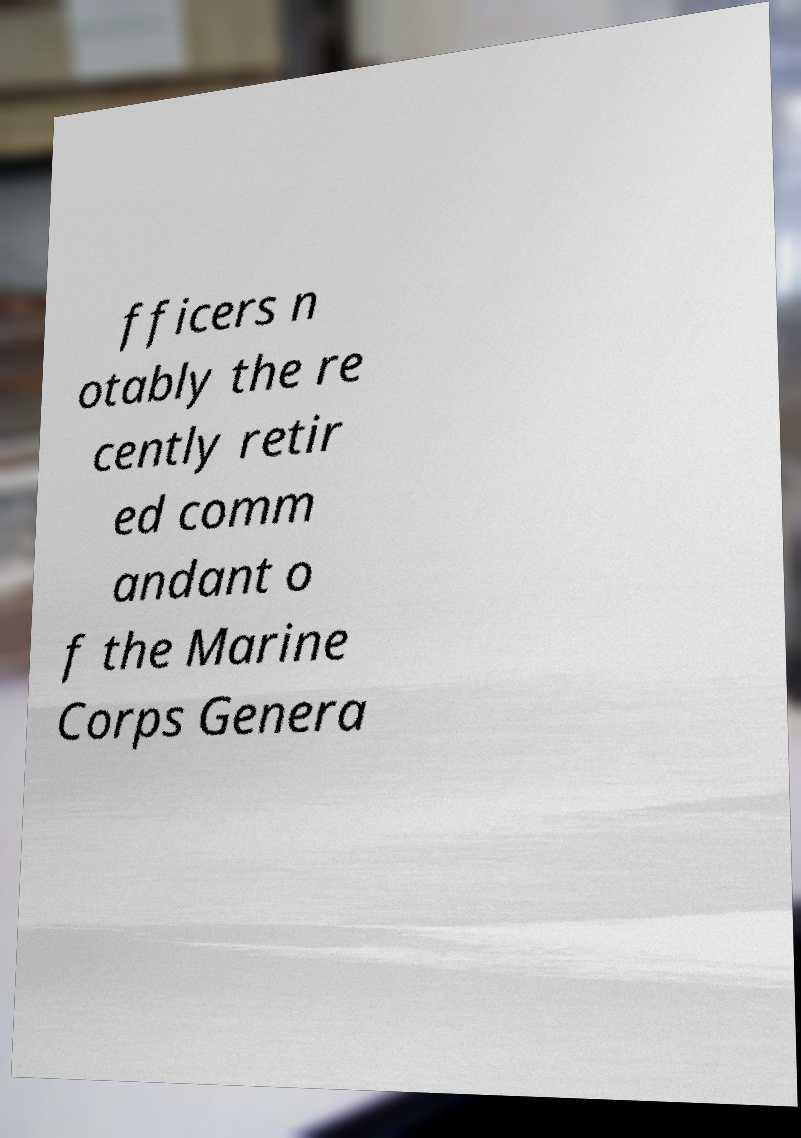Please identify and transcribe the text found in this image. fficers n otably the re cently retir ed comm andant o f the Marine Corps Genera 